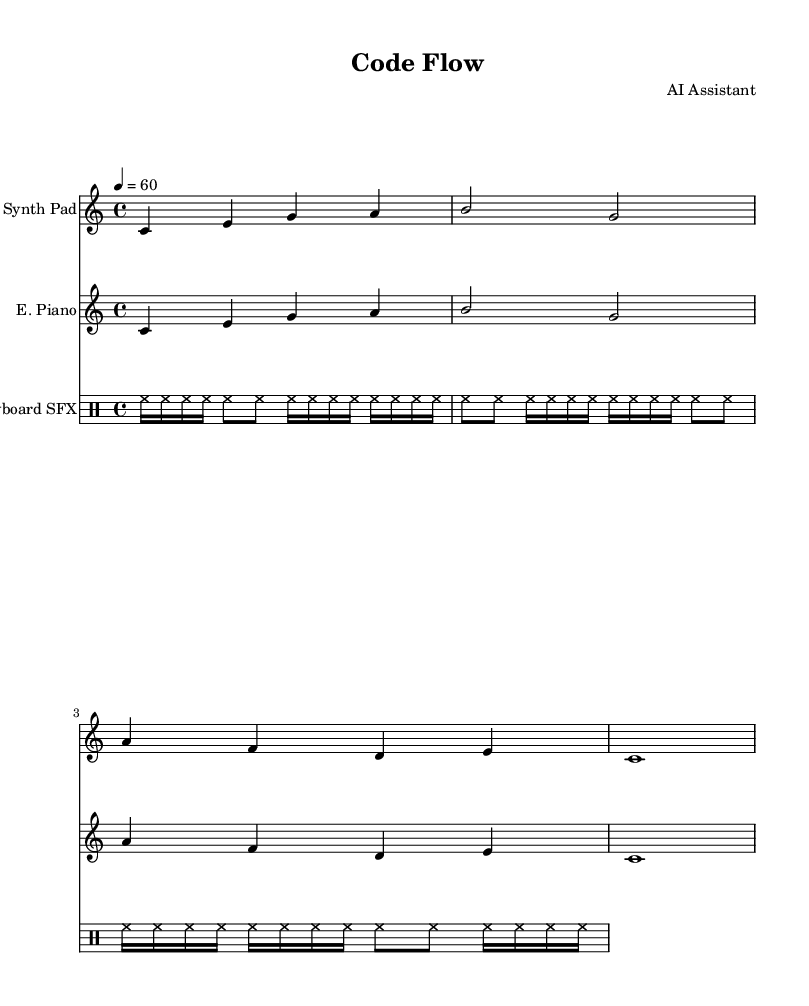What is the key signature of this music? The key signature is C major, which has no sharps or flats.
Answer: C major What is the time signature of this music? The time signature is indicated as 4/4, meaning there are four beats in each measure.
Answer: 4/4 What is the tempo marking of the piece? The tempo marking is set to a quarter note equals sixty beats per minute, which indicates a moderate speed.
Answer: 60 How many measures are in the synthesizer part? The synthesizer part contains four measures, as seen in the grouping of notes.
Answer: 4 What type of instrument is notated for the rhythmic sounds? The rhythmic sounds are notated as being played on drums, indicated by the use of drum notation in the music.
Answer: Drum Which instrument has the highest notes? The synthesizer part contains the highest notes compared to other parts, as its range depicts notes in the higher octave.
Answer: Synth Pad How many different sections are there in this music? There are three distinct sections: Synth Pad, Electric Piano, and Keyboard SFX, each indicated by a separate staff.
Answer: 3 